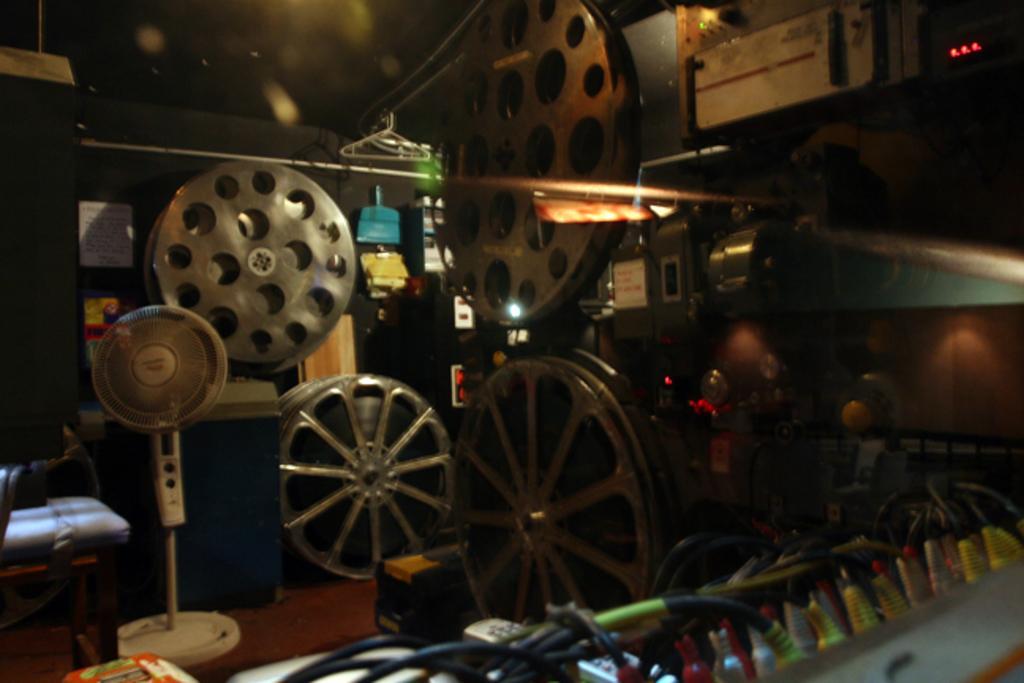Can you describe this image briefly? In this image, on the left side, we can see a fan and a chair. In the background, we can see some metal instrument. 